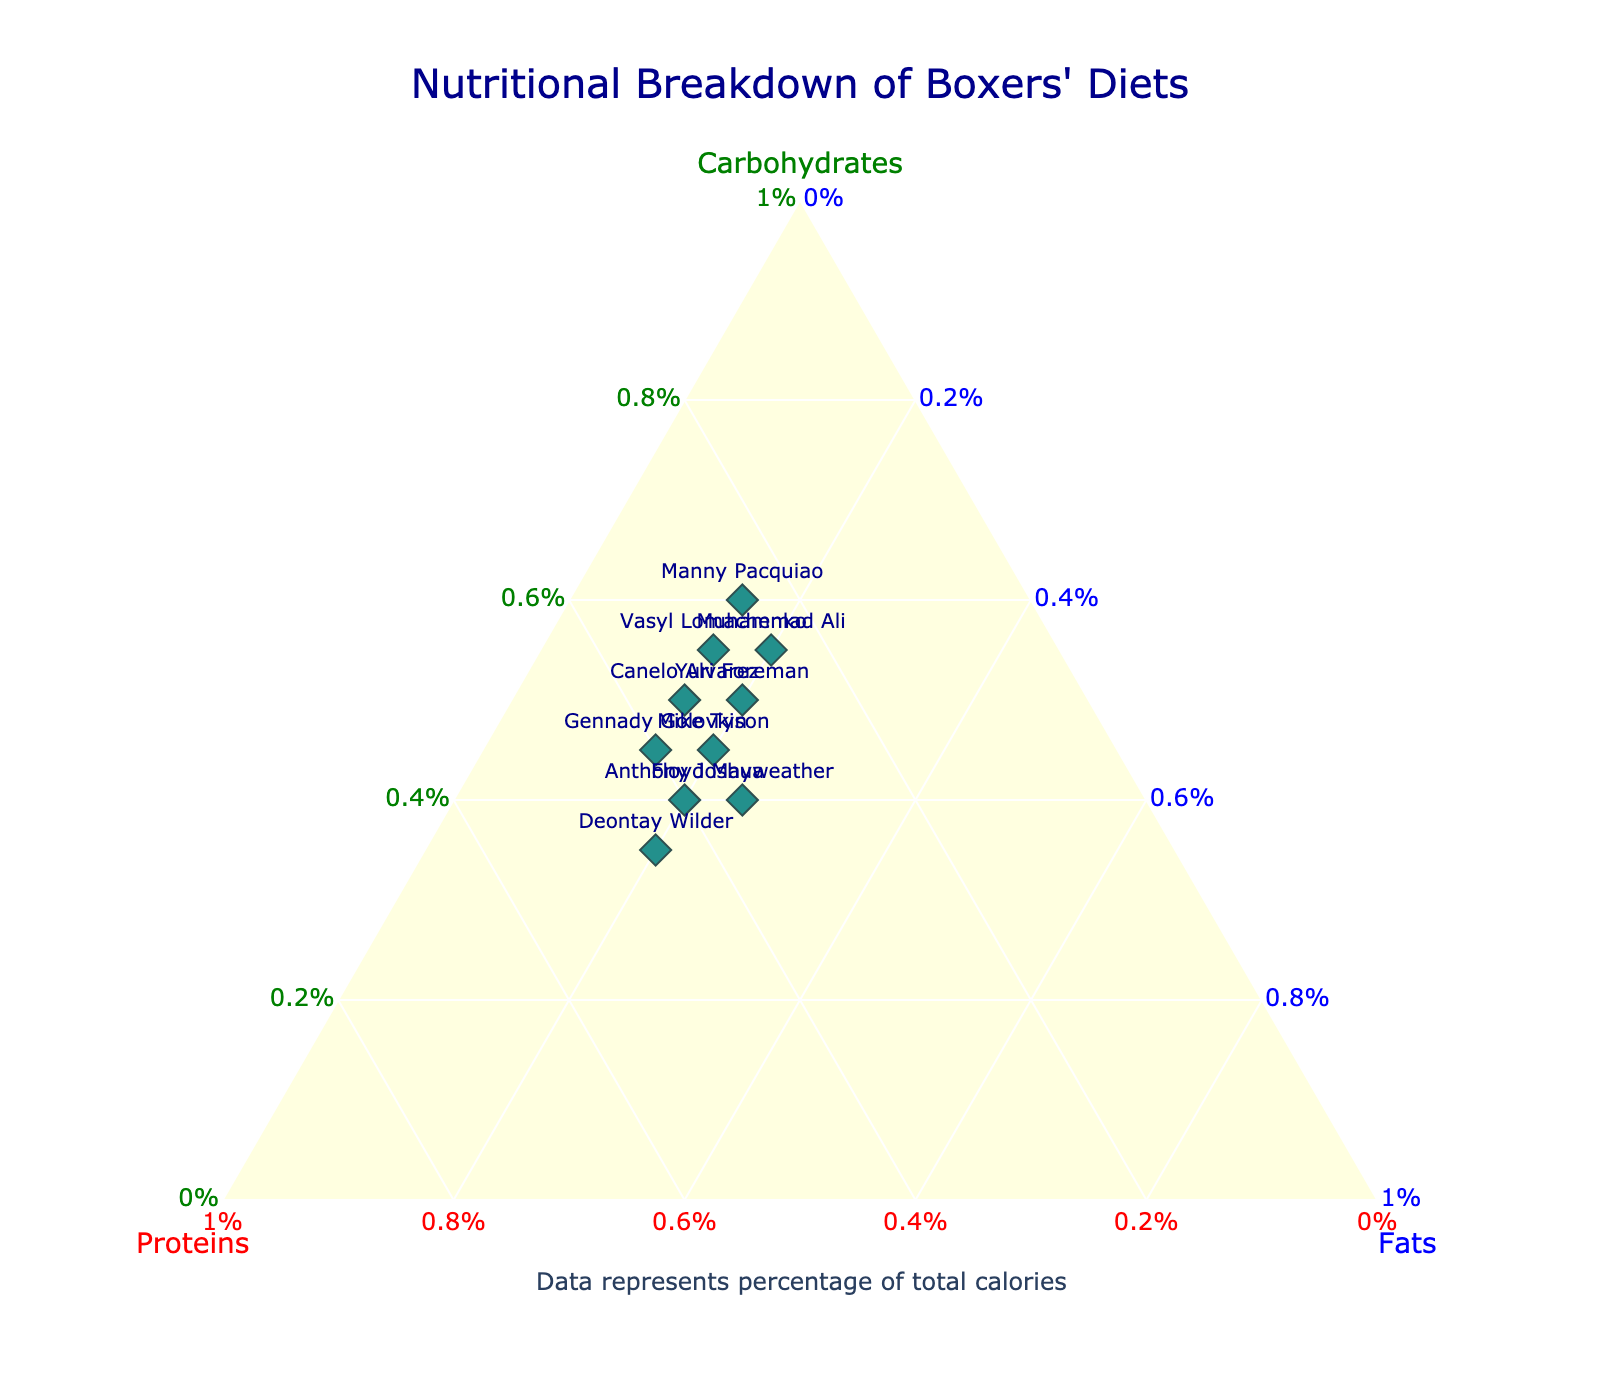What's the title of the plot? The title of the plot is displayed at the top and is usually set to provide a brief description of the data being visualized. In this case, it is centered above the ternary plot.
Answer: Nutritional Breakdown of Boxers' Diets Which axis represents Carbohydrates? The ternary plot has three axes, each representing one of the macronutrients in the diet. The axis for Carbohydrates is indicated by its title on the left side in green.
Answer: The left axis How many boxers have a diet with equal percentages of fats? By looking at the ternary plot, we can see that the diets of multiple boxers share the same percentage of fats, as indicated by their position along the respective axis for fats.
Answer: Five boxers Which boxer has the highest proportion of proteins in their diet? To determine which boxer has the highest proportion of proteins, we locate the point that is closest to the proteins axis, which is located in the center of the ternary plot.
Answer: Deontay Wilder Who has a diet composition with 50% Carbohydrates and 30% Proteins? The points on the plot are labeled with the names of the boxers. By examining the point located at 50% Carbohydrates and 30% Proteins, we find the corresponding boxer's name.
Answer: Yuri Foreman Which boxers have a diet with exactly 20% Fats? By identifying the points aligned at the 20% mark on the Fats axis, we can pick out the corresponding boxers from the labels.
Answer: Yuri Foreman, Muhammad Ali, Mike Tyson, Anthony Joshua, Deontay Wilder What is the range of percentages for proteins in the boxers' diets? To find the range, we identify the lowest and highest values for protein percentages from the ternary plot and subtract the smallest value from the largest value.
Answer: 25% to 45% For which boxers does the sum of Carbohydrates and Proteins equal 90%? We analyze the sum of the Carbohydrates and Proteins percentages and check the respective points for these conditions on the ternary plot.
Answer: Manny Pacquiao, Canelo Alvarez, Vasyl Lomachenko Compare Floyd Mayweather's and Anthony Joshua's diets. Whose diet has a higher proportion of fats? We check the fats percentage for both Floyd Mayweather and Anthony Joshua. Floyd Mayweather's percentage of fats is directly observed from the plot compared to Anthony Joshua's percentage.
Answer: Floyd Mayweather 